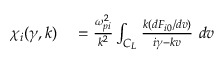Convert formula to latex. <formula><loc_0><loc_0><loc_500><loc_500>\begin{array} { r l } { \chi _ { i } ( \gamma , k ) } & = \frac { \omega _ { p i } ^ { 2 } } { k ^ { 2 } } \int _ { C _ { L } } \frac { k ( d F _ { i 0 } / d v ) } { i \gamma - k v } \ d v } \end{array}</formula> 